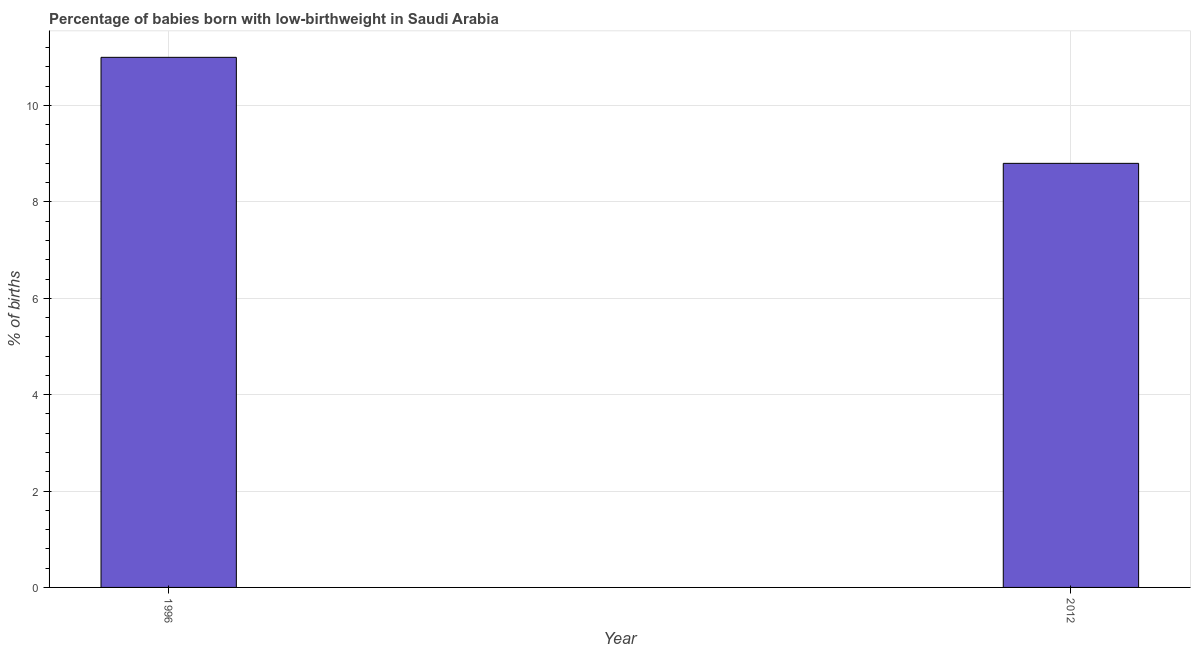Does the graph contain any zero values?
Make the answer very short. No. Does the graph contain grids?
Your response must be concise. Yes. What is the title of the graph?
Keep it short and to the point. Percentage of babies born with low-birthweight in Saudi Arabia. What is the label or title of the Y-axis?
Offer a terse response. % of births. What is the percentage of babies who were born with low-birthweight in 1996?
Give a very brief answer. 11. What is the sum of the percentage of babies who were born with low-birthweight?
Offer a terse response. 19.8. Do a majority of the years between 2012 and 1996 (inclusive) have percentage of babies who were born with low-birthweight greater than 5.6 %?
Keep it short and to the point. No. Is the percentage of babies who were born with low-birthweight in 1996 less than that in 2012?
Offer a terse response. No. In how many years, is the percentage of babies who were born with low-birthweight greater than the average percentage of babies who were born with low-birthweight taken over all years?
Your response must be concise. 1. How many bars are there?
Your answer should be very brief. 2. What is the difference between two consecutive major ticks on the Y-axis?
Keep it short and to the point. 2. What is the % of births of 2012?
Give a very brief answer. 8.8. 